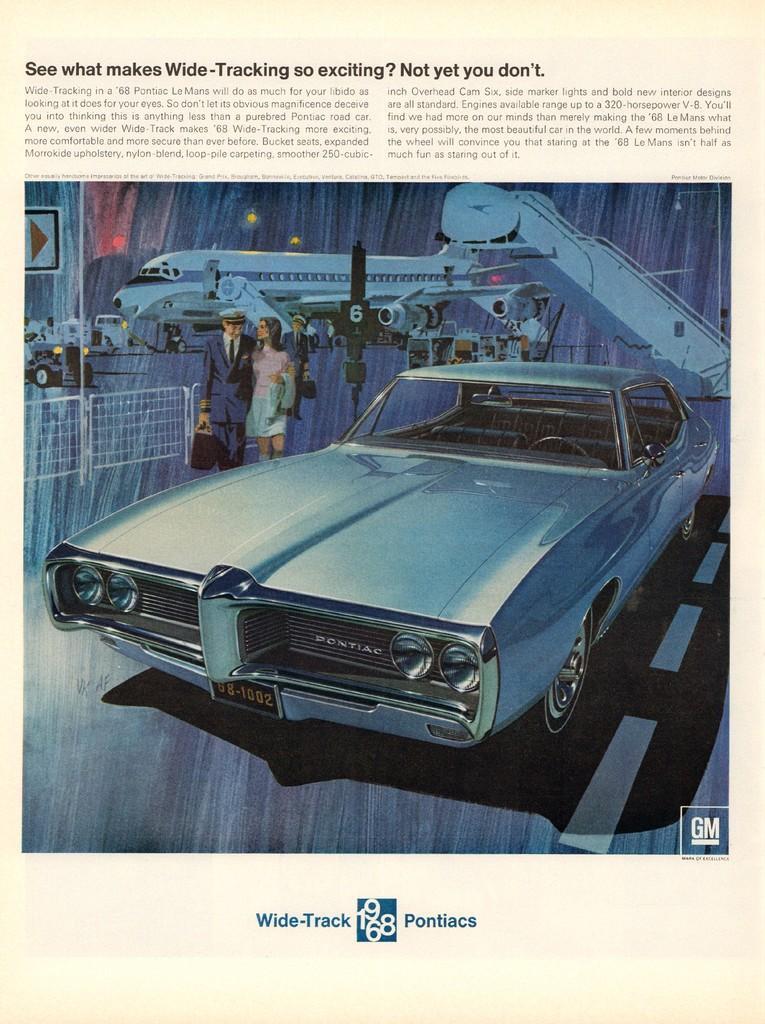In one or two sentences, can you explain what this image depicts? In this image we can see a document. In the document there are the pictures of aeroplane, car, fence, persons and road. 